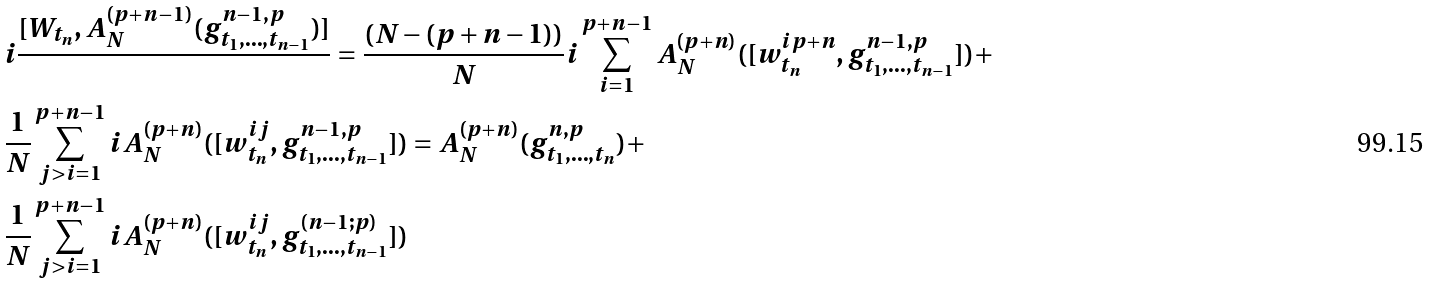Convert formula to latex. <formula><loc_0><loc_0><loc_500><loc_500>& i \frac { [ W _ { t _ { n } } , A ^ { ( p + n - 1 ) } _ { N } ( g ^ { n - 1 , p } _ { t _ { 1 } , \dots , t _ { n - 1 } } ) ] } { } = \frac { ( N - ( p + n - 1 ) ) } { N } i \sum _ { i = 1 } ^ { p + n - 1 } { A ^ { ( p + n ) } _ { N } ( [ w ^ { i p + n } _ { t _ { n } } , g ^ { n - 1 , p } _ { t _ { 1 } , \dots , t _ { n - 1 } } ] } ) + \\ & \frac { 1 } { N } \sum _ { j > i = 1 } ^ { p + n - 1 } i A ^ { ( p + n ) } _ { N } ( [ w ^ { i j } _ { t _ { n } } , g ^ { n - 1 , p } _ { t _ { 1 } , \dots , t _ { n - 1 } } ] ) = A ^ { ( p + n ) } _ { N } ( g ^ { n , p } _ { t _ { 1 } , \dots , t _ { n } } ) + \\ & \frac { 1 } { N } \sum _ { j > i = 1 } ^ { p + n - 1 } i A ^ { ( p + n ) } _ { N } ( { [ w _ { t _ { n } } ^ { i j } , g ^ { ( n - 1 ; p ) } _ { t _ { 1 } , \dots , t _ { n - 1 } } ] } )</formula> 